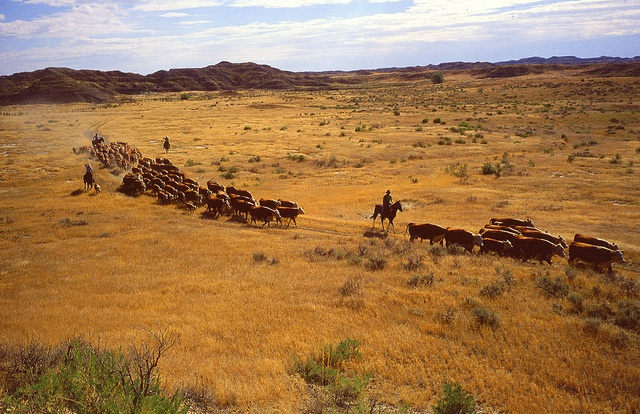Describe the objects in this image and their specific colors. I can see cow in gray, black, maroon, brown, and tan tones, cow in gray, black, maroon, and brown tones, cow in gray, black, maroon, and brown tones, cow in gray, maroon, olive, and orange tones, and cow in gray, maroon, olive, and brown tones in this image. 